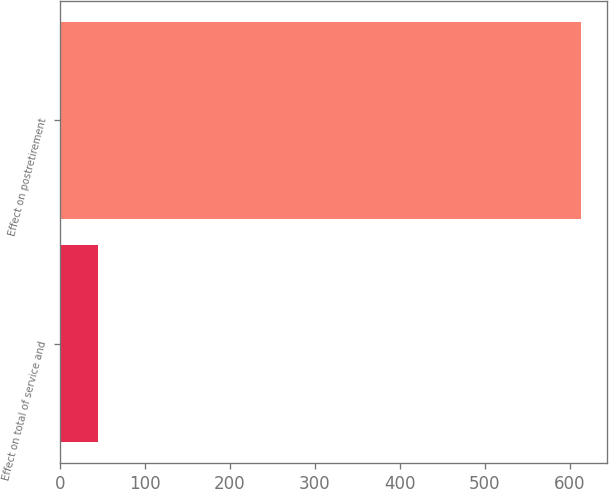Convert chart to OTSL. <chart><loc_0><loc_0><loc_500><loc_500><bar_chart><fcel>Effect on total of service and<fcel>Effect on postretirement<nl><fcel>45<fcel>613<nl></chart> 